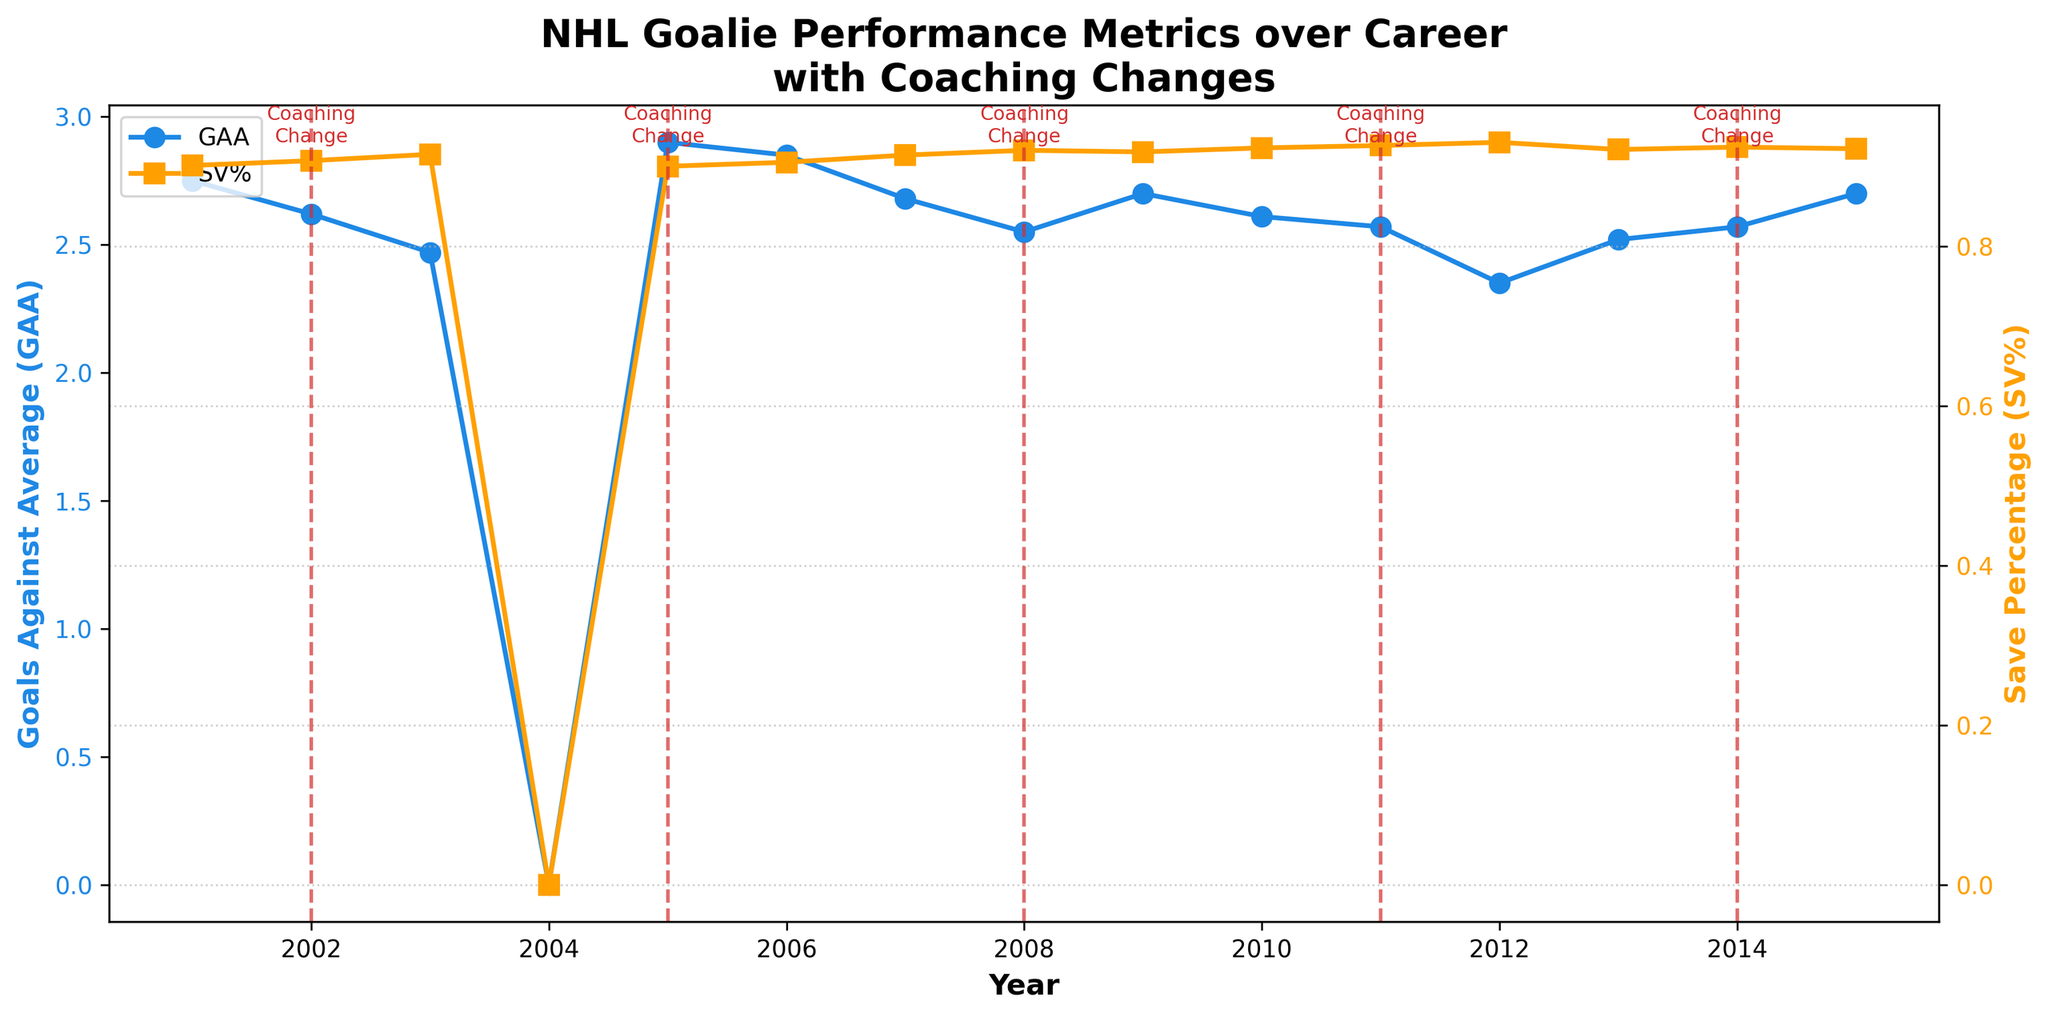what is the title of the plot? The title is displayed at the top of the plot in bold font. It reads "NHL Goalie Performance Metrics over Career with Coaching Changes".
Answer: NHL Goalie Performance Metrics over Career with Coaching Changes What years show coaching changes? The vertical dashed red lines represent years with coaching changes. These lines are annotated with the text "Coaching\nChange" at the top of the plot. The years are 2002, 2005, 2008, 2011, and 2014.
Answer: 2002, 2005, 2008, 2011, 2014 How does the GAA trend change over the career without considering coaching changes? The GAA fluctuates over the years. It starts around 2.75 in 2001, decreases to a low of 2.35 in 2012, and increases towards the end of the career, reaching around 2.70 in 2015. This shows an overall decrease for the first part of the career, followed by a slight increase towards the end.
Answer: Decreases initially, then slightly increases Did the goalie play any games in 2004-2005? The x-axis indicates the years, and looking at the data point for 2004-2005, the games played count is zero, indicating no games were played that season.
Answer: No What happens to the save percentage (SV%) after each coaching change? To determine this, look at the yellow line with square markers around the vertical dashed lines. 
1. After 2002: SV% increased from ~0.901 to ~0.907.
2. After 2005: SV% slightly increased from ~0.900 to ~0.905.
3. After 2008: SV% increased from ~0.914 to ~0.920.
4. After 2011: SV% increased from ~0.918 to ~0.926.
5. After 2014: SV% remained fairly stable around 0.922.
Answer: Mostly increases after coaching changes What's the difference in save percentage (SV%) between the beginning and end of the career? The save percentage (SV%) in the first year (2001) is about 0.901. By the last year (2015-2016), it increases to around 0.922. To find the difference, subtract the initial SV% from the final SV% (0.922 - 0.901 = 0.021).
Answer: 0.021 Did the Goals Against Average (GAA) reach its lowest value during a year with a coaching change? The lowest GAA appears to be in the year 2012 with a value of ~2.35. According to the vertical lines marking coaching changes, 2012 is not marked as a year with a coaching change.
Answer: No During which year did GAA exceed 2.85 after a coaching change? After identifying the coaching change years, look at the GAA trend. Following 2005, the GAA slightly exceeds 2.85 in the following year, which is 2006-2007 (2.85).
Answer: 2006 Is there any year where the save percentage (SV%) and GAA trends have opposite directions in the year following a coaching change? After examining the data, in 2004-2005, after the coaching change in 2005, the GAA slightly increases, while the save percentage (SV%) increases slightly in the immediate following year (2006-2007).
Answer: No Did any year have both the highest save percentage and the lowest goals against average? To identify this, look for the year with the highest save percentage (~0.930) and the lowest GAA (~2.35), which is the same year, 2012-2013.
Answer: Yes, 2012 